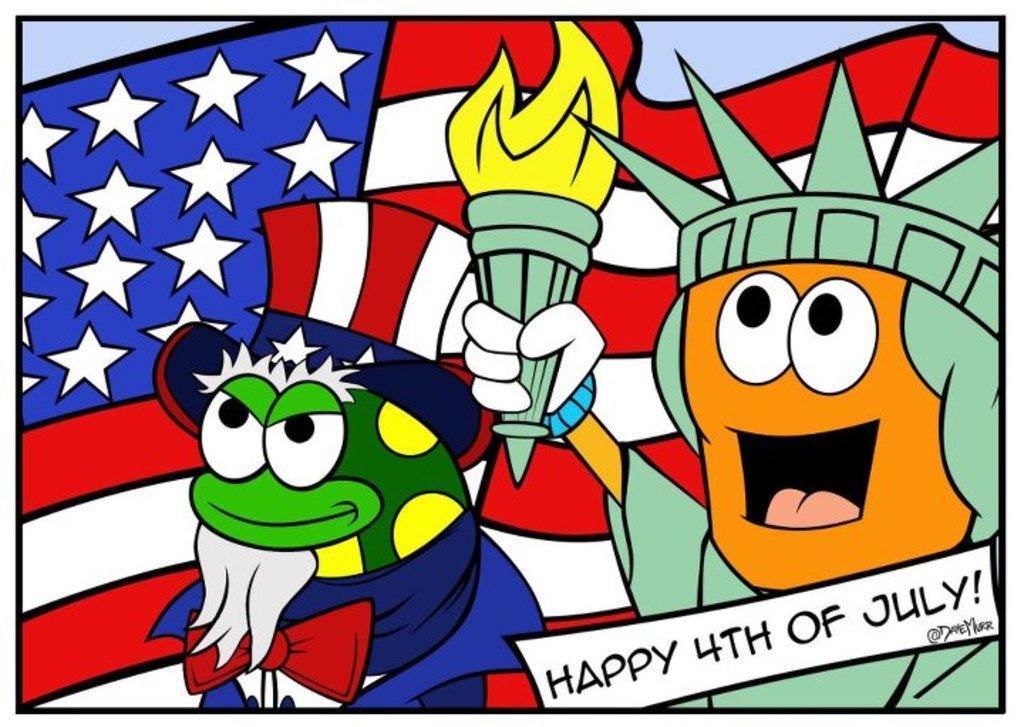Describe this image in one or two sentences. In this image I can see the animated picture in which I can see a flag which is white, blue and red in color. I can see a orange and green colored thing is holding a light and a green and yellow colored thing wearing blue colored dress. 